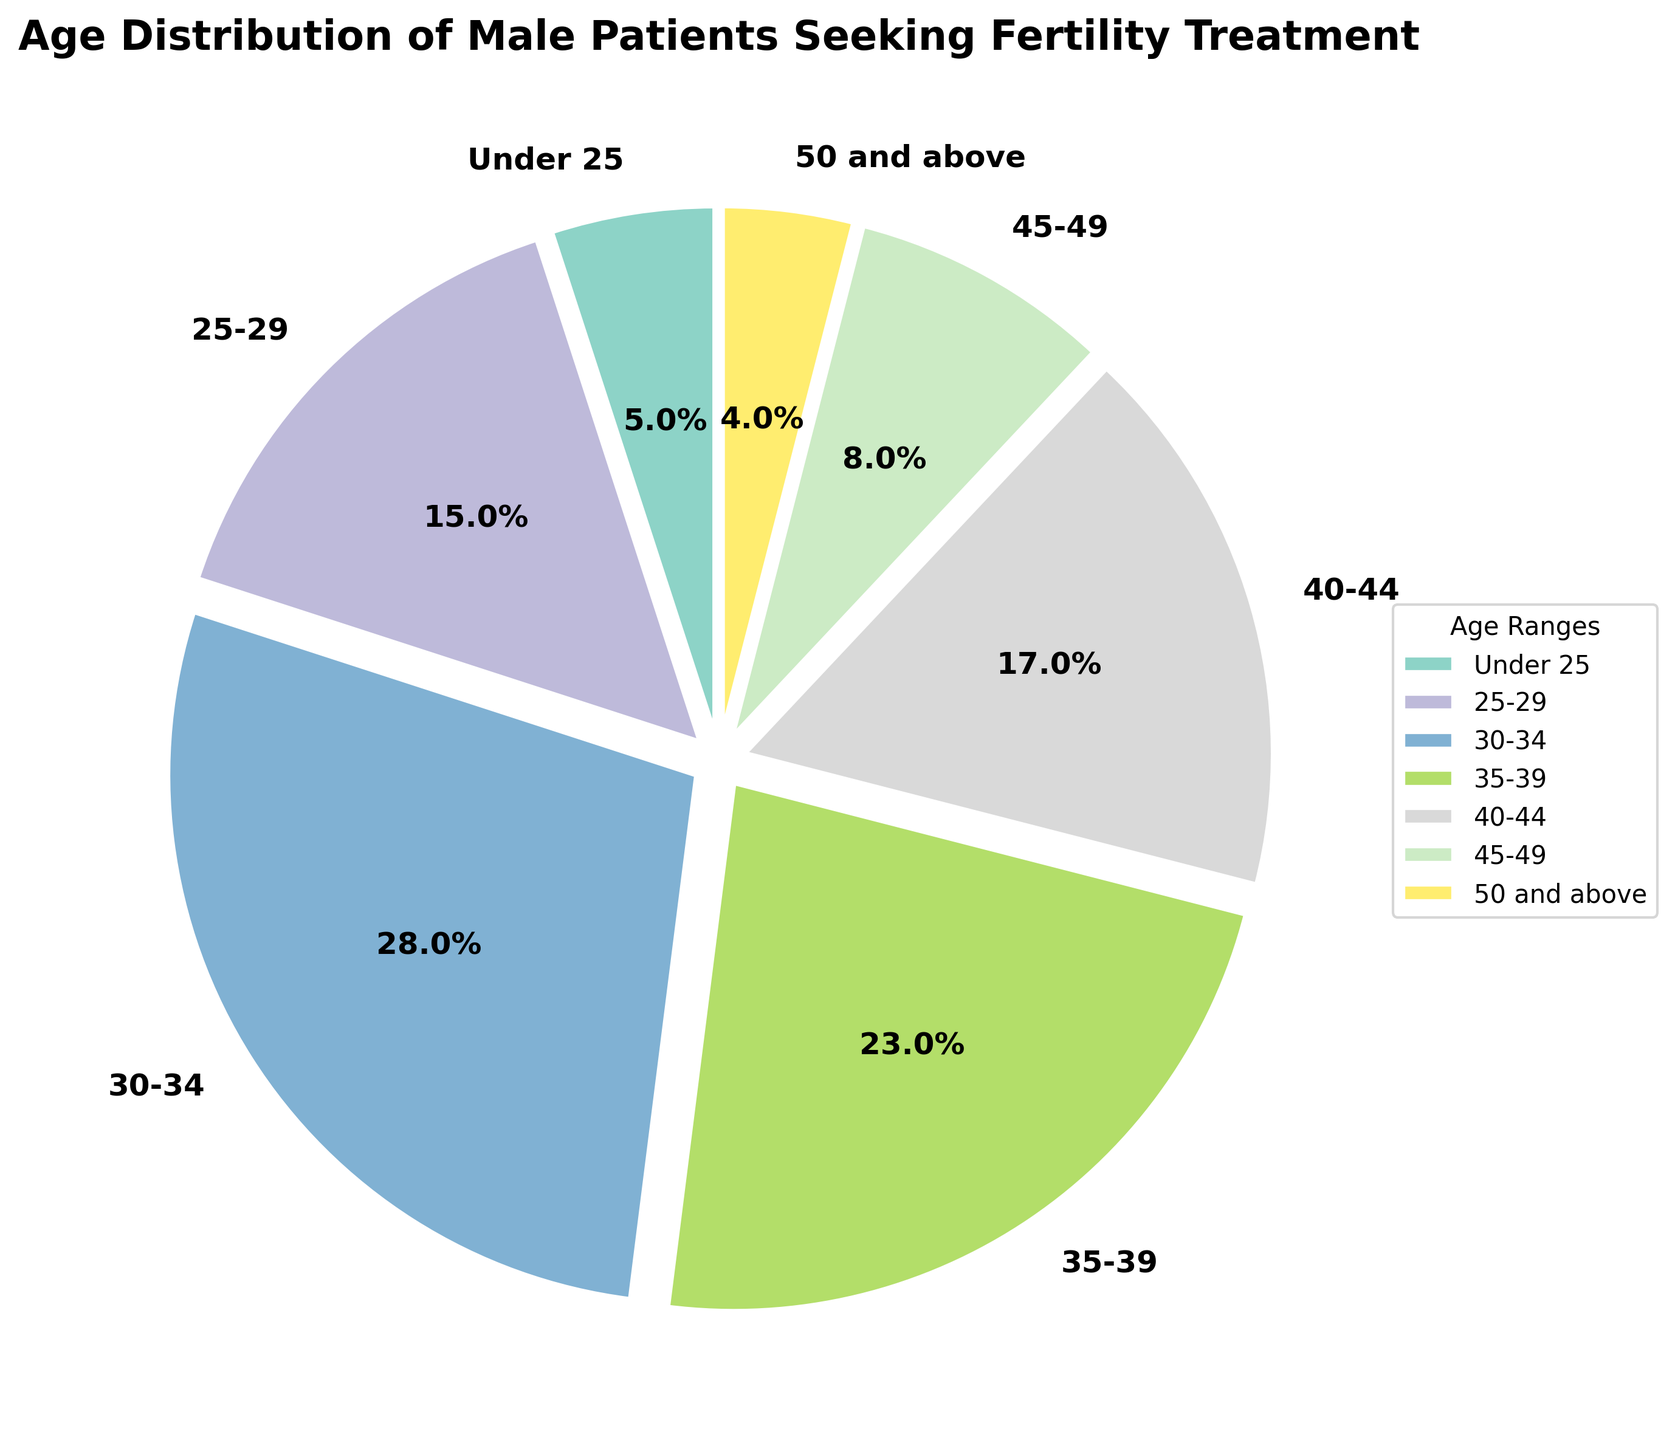What's the total percentage of male patients aged under 35? To find the total percentage of male patients under 35, sum the percentages of the age ranges "Under 25," "25-29," and "30-34." So, 5% (Under 25) + 15% (25-29) + 28% (30-34) = 48%.
Answer: 48% Which age group has the highest representation among male patients seeking fertility treatment? By looking at the pie chart, the age group "30-34" has the largest slice, indicating the highest percentage.
Answer: 30-34 How does the percentage of male patients aged 35-39 compare to those aged 40-44? The percentage for "35-39" is 23%, and for "40-44" it is 17%. Therefore, the percentage for "35-39" is higher than that for "40-44."
Answer: 35-39 > 40-44 What proportion of male patients are aged 45 and above? Sum the percentages of "45-49" and "50 and above." So, 8% (45-49) + 4% (50 and above) = 12%.
Answer: 12% What percentage of male patients are in their twenties? To find this, sum the percentages of the age ranges "Under 25" and "25-29." So, 5% (Under 25) + 15% (25-29) = 20%.
Answer: 20% If you combine the age groups 35-39 and 40-44, does their total percentage exceed the percentage of those aged 30-34? Sum the percentages of the age ranges "35-39" and "40-44." So, 23% (35-39) + 17% (40-44) = 40%. The percentage for "30-34" is 28%. Therefore, 40% is greater than 28%.
Answer: Yes In the pie chart, which age group's wedge has the smallest area? The smallest wedge in the pie chart represents the age group "50 and above," which has a percentage of 4%.
Answer: 50 and above How much larger is the percentage of male patients aged 30-34 compared to those aged under 25? The percentage for "30-34" is 28%, and for "Under 25" it is 5%. The difference is 28% - 5% = 23%.
Answer: 23% What is the combined percentage of male patients aged between 30 and 39? Sum the percentages of the age ranges "30-34" and "35-39." So, 28% (30-34) + 23% (35-39) = 51%.
Answer: 51% 